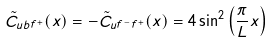Convert formula to latex. <formula><loc_0><loc_0><loc_500><loc_500>\tilde { C } _ { u b f ^ { + } } ( x ) = - \tilde { C } _ { u f ^ { - } f ^ { + } } ( x ) = 4 \sin ^ { 2 } \left ( \frac { \pi } { L } x \right )</formula> 